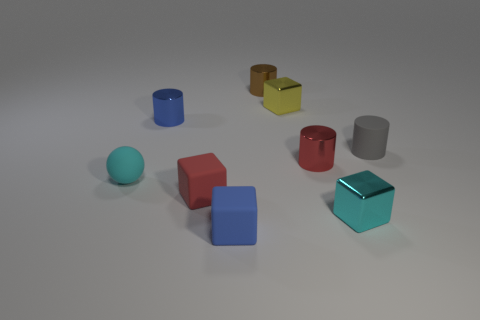How many objects are red cylinders or tiny cyan things right of the sphere?
Keep it short and to the point. 2. How many cylinders are there?
Keep it short and to the point. 4. Is there a metallic object that has the same size as the cyan metal block?
Offer a terse response. Yes. Are there fewer brown cylinders in front of the tiny rubber cylinder than gray cubes?
Offer a very short reply. No. There is a cyan cube that is made of the same material as the yellow block; what is its size?
Make the answer very short. Small. How many shiny cubes are the same color as the small matte sphere?
Your response must be concise. 1. Is the number of small brown metallic objects that are in front of the small brown metal cylinder less than the number of shiny objects that are to the right of the tiny red rubber thing?
Your response must be concise. Yes. There is a tiny red thing that is to the left of the brown cylinder; does it have the same shape as the tiny cyan shiny object?
Keep it short and to the point. Yes. Does the blue thing behind the small blue rubber block have the same material as the tiny cyan cube?
Provide a short and direct response. Yes. The blue object that is in front of the cyan object that is behind the cyan metal thing that is behind the blue matte cube is made of what material?
Make the answer very short. Rubber. 